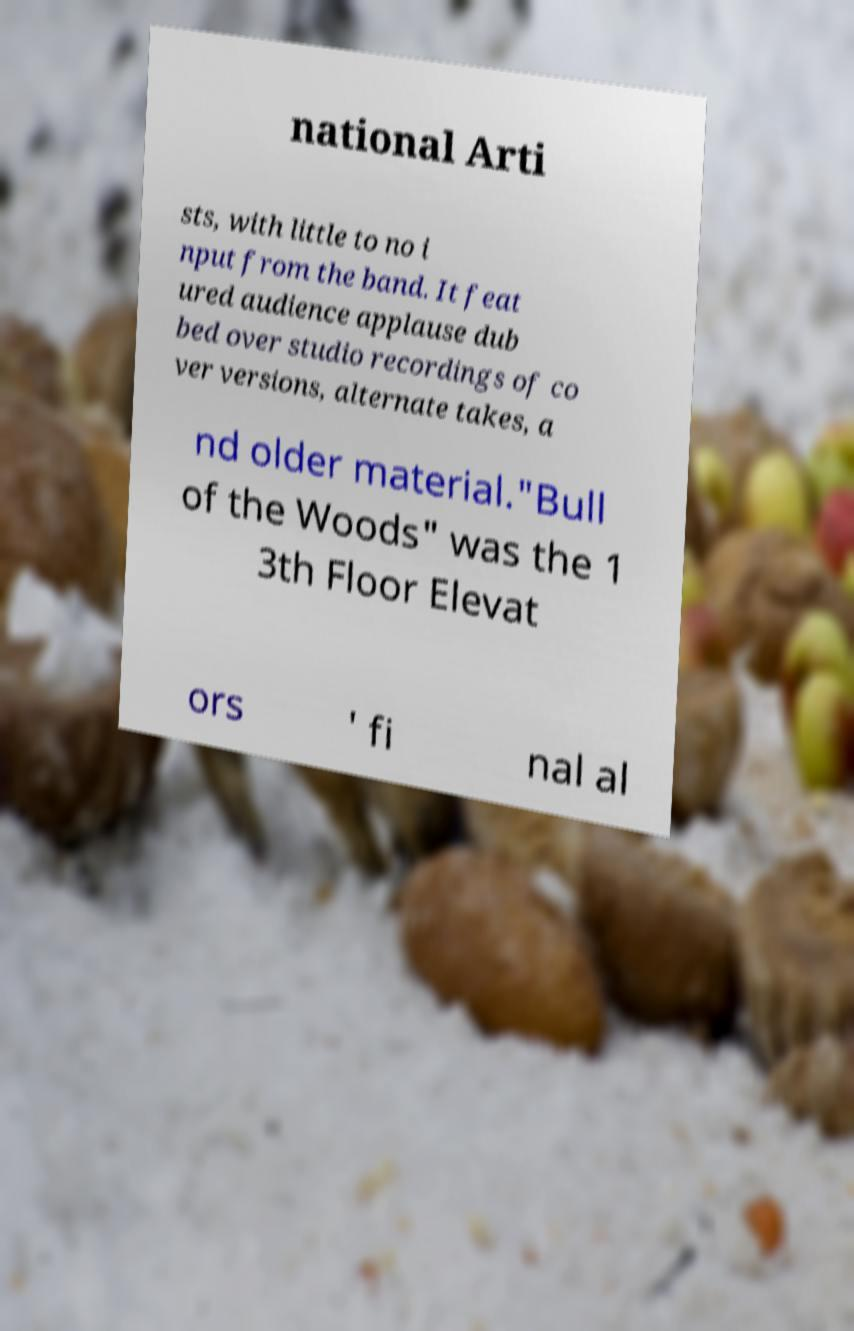What messages or text are displayed in this image? I need them in a readable, typed format. national Arti sts, with little to no i nput from the band. It feat ured audience applause dub bed over studio recordings of co ver versions, alternate takes, a nd older material."Bull of the Woods" was the 1 3th Floor Elevat ors ' fi nal al 